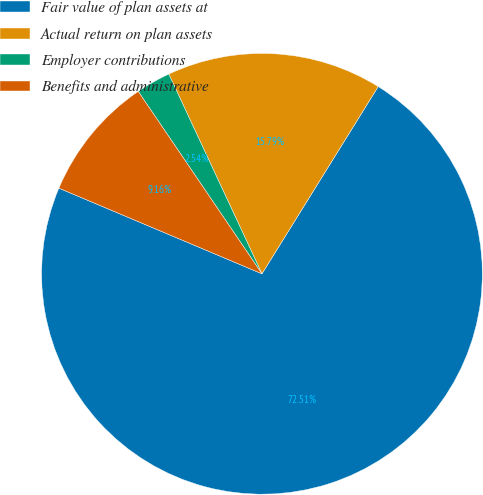<chart> <loc_0><loc_0><loc_500><loc_500><pie_chart><fcel>Fair value of plan assets at<fcel>Actual return on plan assets<fcel>Employer contributions<fcel>Benefits and administrative<nl><fcel>72.51%<fcel>15.79%<fcel>2.54%<fcel>9.16%<nl></chart> 